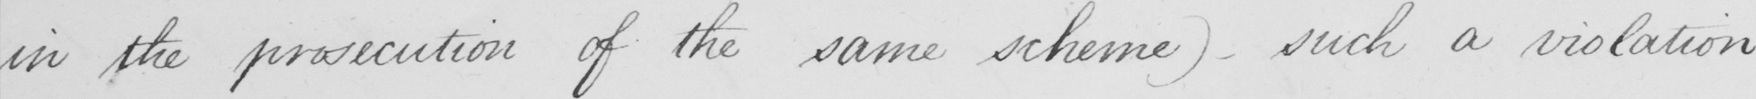What is written in this line of handwriting? in the prosecution of the same scheme )   _  such a violation 